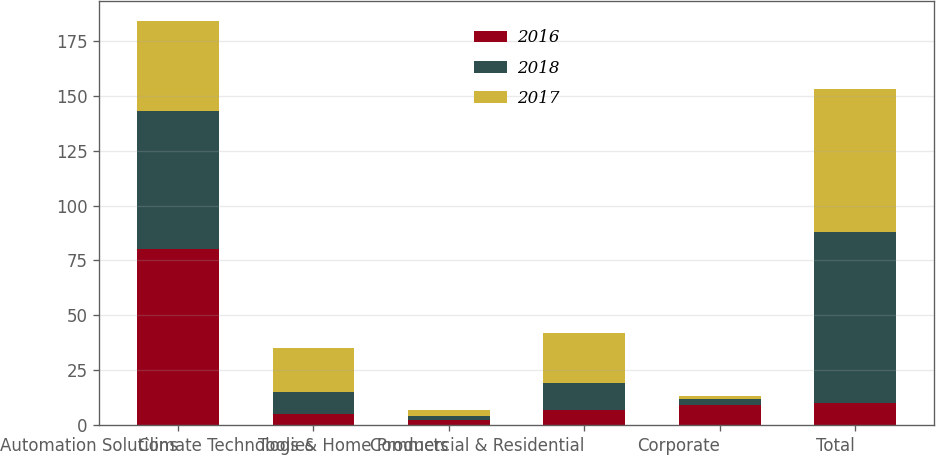Convert chart to OTSL. <chart><loc_0><loc_0><loc_500><loc_500><stacked_bar_chart><ecel><fcel>Automation Solutions<fcel>Climate Technologies<fcel>Tools & Home Products<fcel>Commercial & Residential<fcel>Corporate<fcel>Total<nl><fcel>2016<fcel>80<fcel>5<fcel>2<fcel>7<fcel>9<fcel>10<nl><fcel>2018<fcel>63<fcel>10<fcel>2<fcel>12<fcel>3<fcel>78<nl><fcel>2017<fcel>41<fcel>20<fcel>3<fcel>23<fcel>1<fcel>65<nl></chart> 